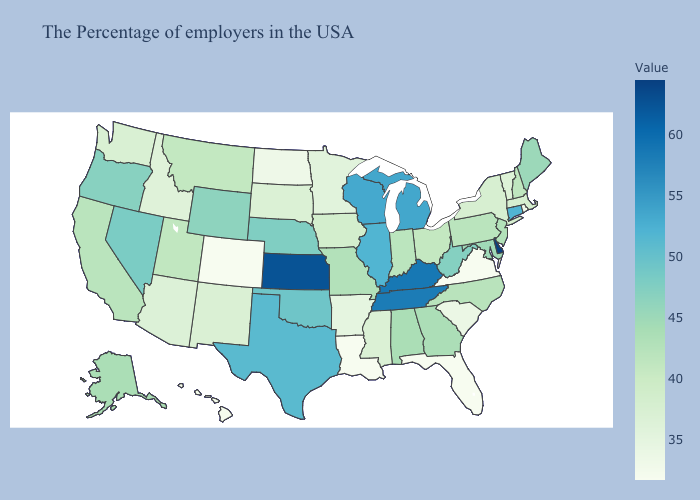Among the states that border Minnesota , does South Dakota have the highest value?
Be succinct. No. Among the states that border Mississippi , does Arkansas have the lowest value?
Short answer required. No. Which states have the lowest value in the USA?
Keep it brief. Virginia, Florida, Louisiana, Colorado. Does Delaware have the highest value in the USA?
Give a very brief answer. Yes. Among the states that border Florida , which have the lowest value?
Answer briefly. Georgia. Which states have the lowest value in the West?
Keep it brief. Colorado. Which states have the highest value in the USA?
Quick response, please. Delaware. Does Maine have a lower value than Minnesota?
Give a very brief answer. No. 